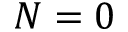Convert formula to latex. <formula><loc_0><loc_0><loc_500><loc_500>N = 0</formula> 